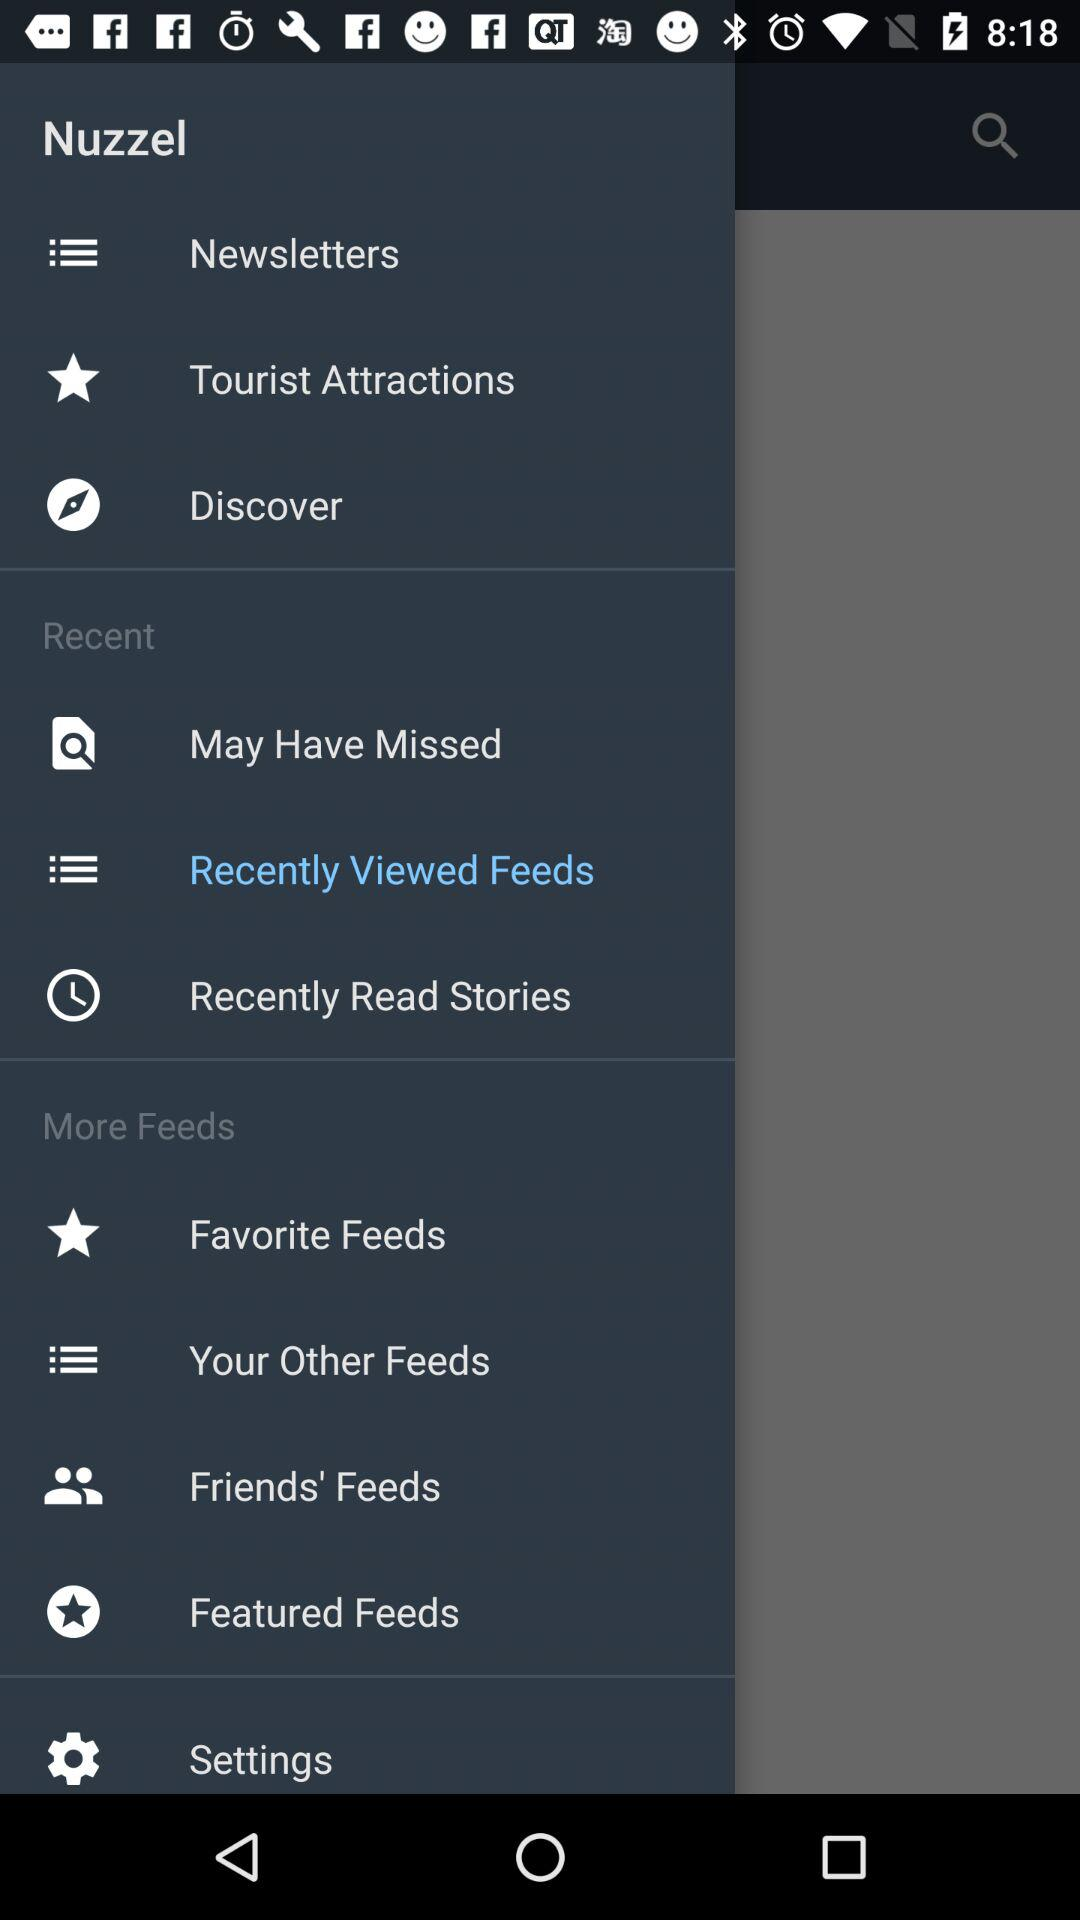What is the name of the application? The name of the application is "Nuzzel". 